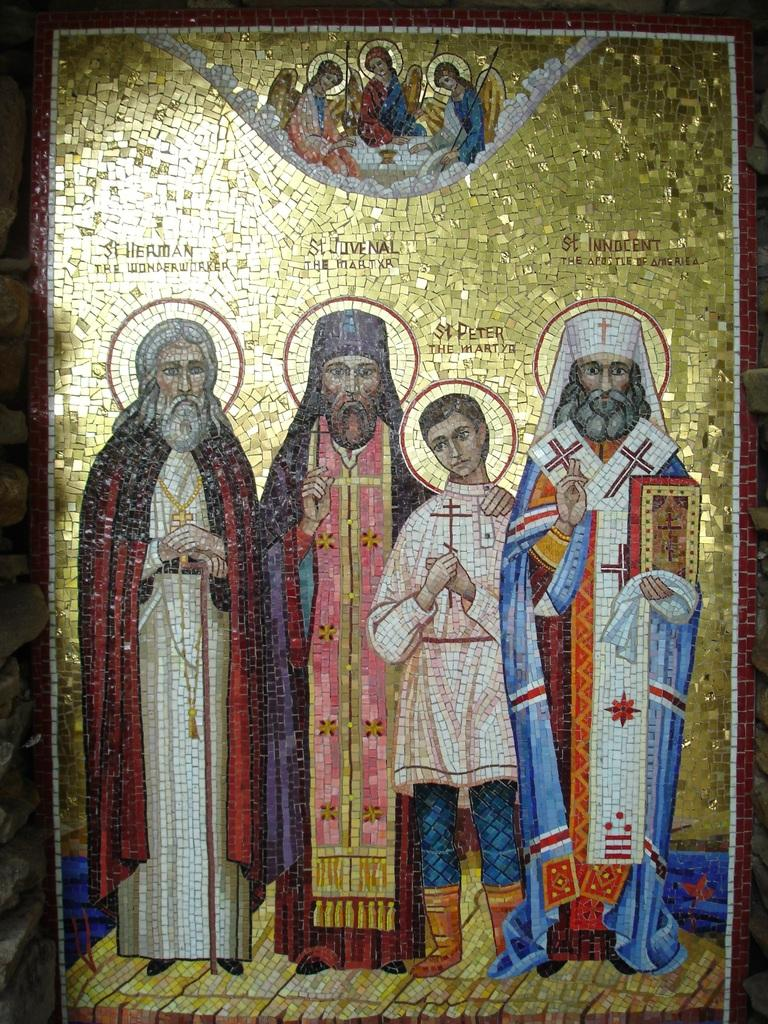What is the color of the object in the image? The object in the image is golden-colored. What can be seen on the object? The object has a depiction of people. Is there any text present in the image? Yes, there is text written on the top side of the image. How many boys are depicted with the father in the image? There is no father or boys depicted in the image; it only features a golden-colored object with a depiction of people. What type of coil is wrapped around the object in the image? There is no coil present in the image; the object is described as having a depiction of people and text. 